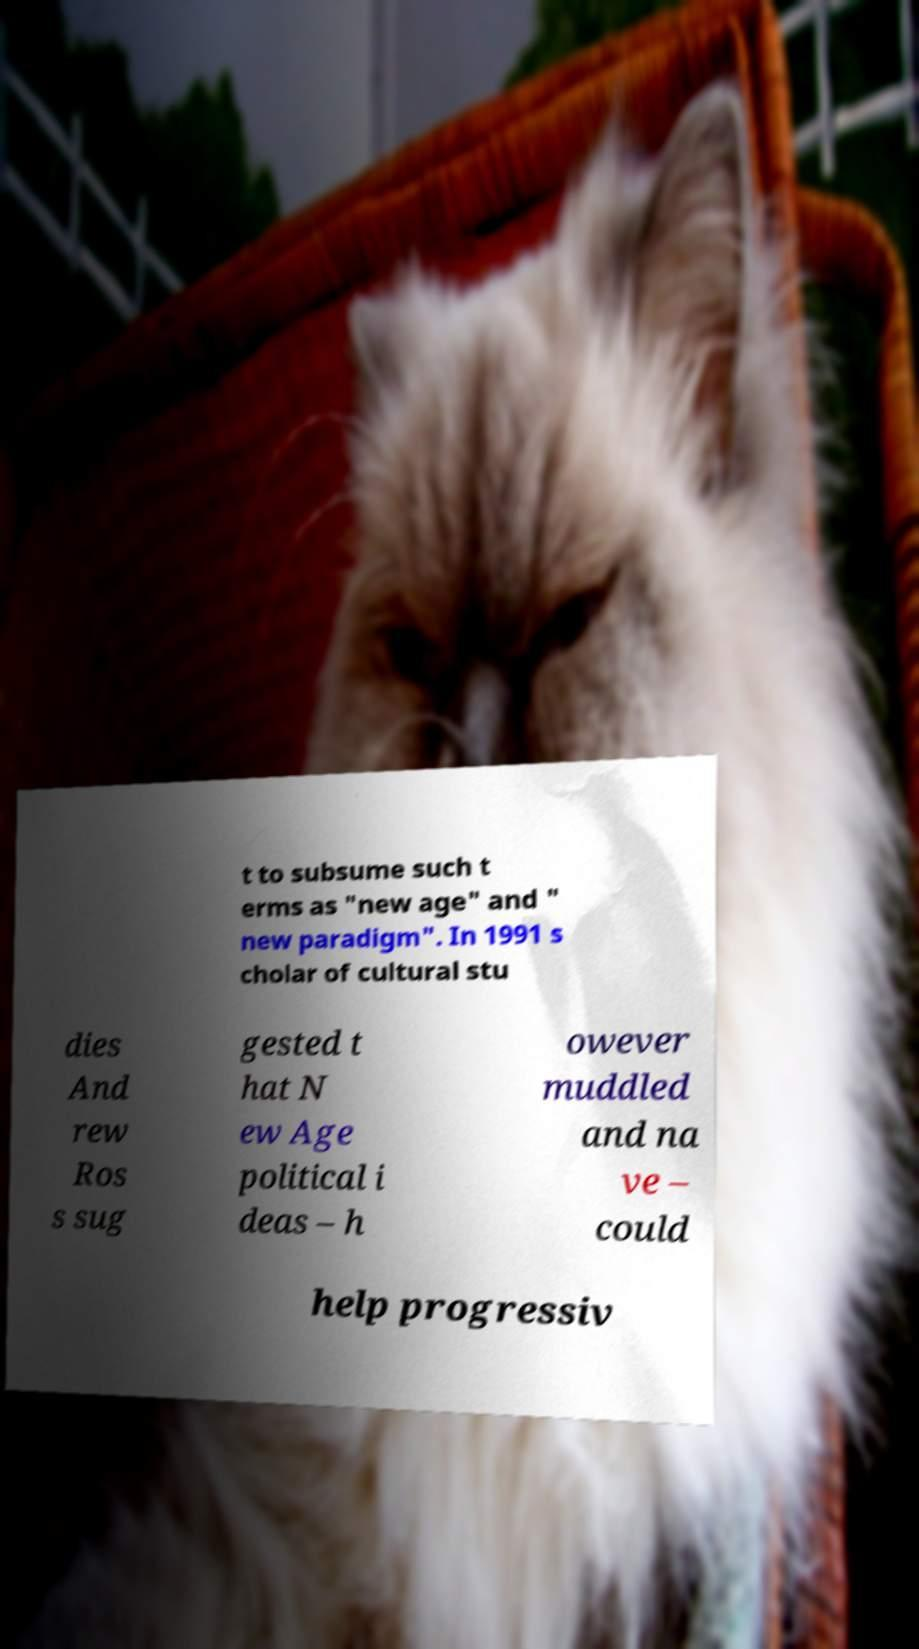Could you extract and type out the text from this image? t to subsume such t erms as "new age" and " new paradigm". In 1991 s cholar of cultural stu dies And rew Ros s sug gested t hat N ew Age political i deas – h owever muddled and na ve – could help progressiv 